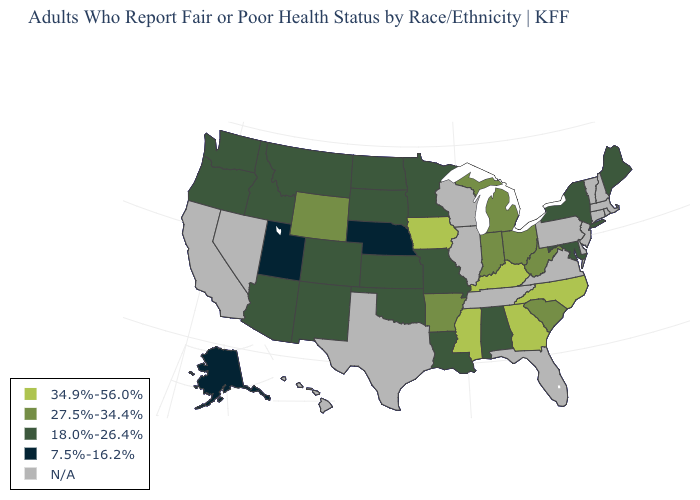Name the states that have a value in the range 7.5%-16.2%?
Quick response, please. Alaska, Nebraska, Utah. Name the states that have a value in the range 34.9%-56.0%?
Be succinct. Georgia, Iowa, Kentucky, Mississippi, North Carolina. What is the value of Indiana?
Answer briefly. 27.5%-34.4%. Which states have the highest value in the USA?
Concise answer only. Georgia, Iowa, Kentucky, Mississippi, North Carolina. Name the states that have a value in the range N/A?
Write a very short answer. California, Connecticut, Delaware, Florida, Hawaii, Illinois, Massachusetts, Nevada, New Hampshire, New Jersey, Pennsylvania, Rhode Island, Tennessee, Texas, Vermont, Virginia, Wisconsin. Name the states that have a value in the range 34.9%-56.0%?
Give a very brief answer. Georgia, Iowa, Kentucky, Mississippi, North Carolina. What is the lowest value in states that border Michigan?
Answer briefly. 27.5%-34.4%. What is the value of Wyoming?
Concise answer only. 27.5%-34.4%. Among the states that border Michigan , which have the highest value?
Quick response, please. Indiana, Ohio. Name the states that have a value in the range 34.9%-56.0%?
Give a very brief answer. Georgia, Iowa, Kentucky, Mississippi, North Carolina. Among the states that border Utah , which have the highest value?
Write a very short answer. Wyoming. Does the map have missing data?
Short answer required. Yes. Which states have the lowest value in the MidWest?
Be succinct. Nebraska. What is the highest value in the USA?
Short answer required. 34.9%-56.0%. What is the highest value in the West ?
Quick response, please. 27.5%-34.4%. 